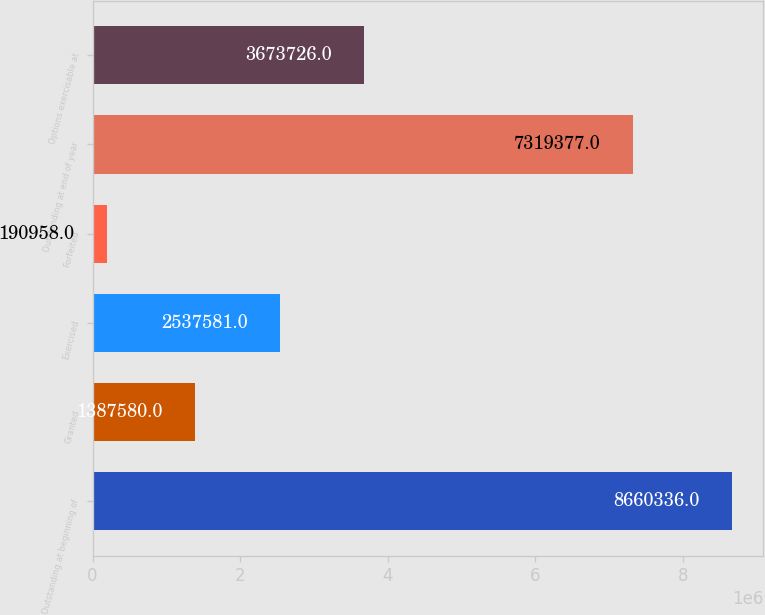Convert chart to OTSL. <chart><loc_0><loc_0><loc_500><loc_500><bar_chart><fcel>Outstanding at beginning of<fcel>Granted<fcel>Exercised<fcel>Forfeited<fcel>Outstanding at end of year<fcel>Options exercisable at<nl><fcel>8.66034e+06<fcel>1.38758e+06<fcel>2.53758e+06<fcel>190958<fcel>7.31938e+06<fcel>3.67373e+06<nl></chart> 